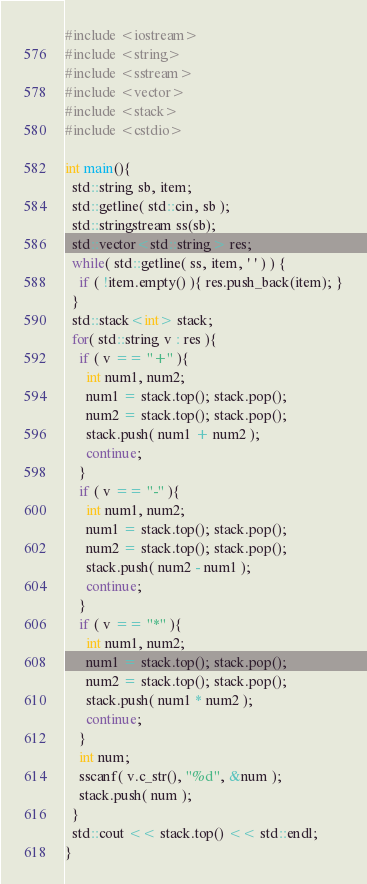Convert code to text. <code><loc_0><loc_0><loc_500><loc_500><_C++_>#include <iostream>
#include <string>
#include <sstream>
#include <vector>
#include <stack>
#include <cstdio>

int main(){
  std::string sb, item;
  std::getline( std::cin, sb );
  std::stringstream ss(sb);
  std::vector<std::string> res;
  while( std::getline( ss, item, ' ' ) ) {
    if ( !item.empty() ){ res.push_back(item); }
  }
  std::stack<int> stack;
  for( std::string v : res ){
    if ( v == "+" ){
      int num1, num2;
      num1 = stack.top(); stack.pop();
      num2 = stack.top(); stack.pop();
      stack.push( num1 + num2 );
      continue;
    }
    if ( v == "-" ){
      int num1, num2;
      num1 = stack.top(); stack.pop();
      num2 = stack.top(); stack.pop();
      stack.push( num2 - num1 );
      continue;
    }
    if ( v == "*" ){
      int num1, num2;
      num1 = stack.top(); stack.pop();
      num2 = stack.top(); stack.pop();
      stack.push( num1 * num2 );
      continue;
    }
    int num;
    sscanf( v.c_str(), "%d", &num );
    stack.push( num );
  }
  std::cout << stack.top() << std::endl;
}
</code> 